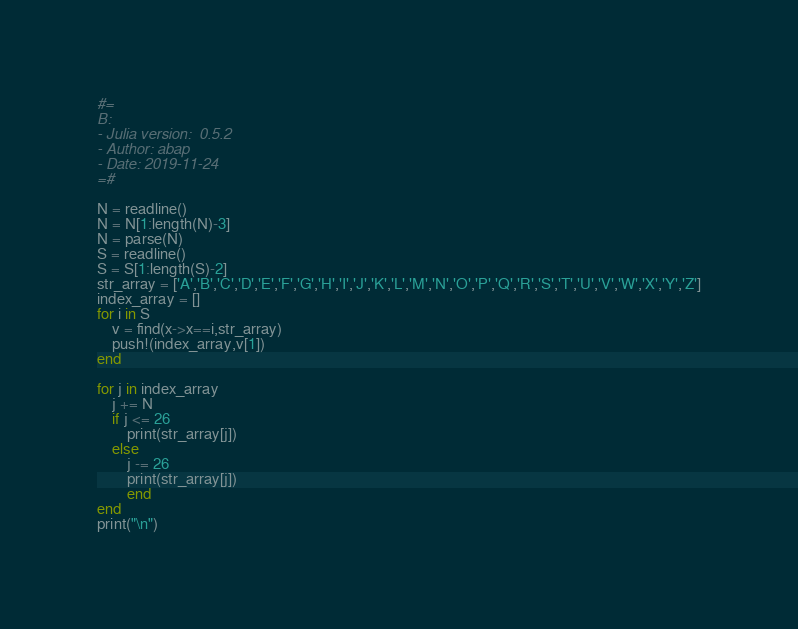<code> <loc_0><loc_0><loc_500><loc_500><_Julia_>#=
B:
- Julia version:  0.5.2
- Author: abap
- Date: 2019-11-24
=#

N = readline()
N = N[1:length(N)-3]
N = parse(N)
S = readline()
S = S[1:length(S)-2]
str_array = ['A','B','C','D','E','F','G','H','I','J','K','L','M','N','O','P','Q','R','S','T','U','V','W','X','Y','Z']
index_array = []
for i in S
    v = find(x->x==i,str_array)
    push!(index_array,v[1])
end

for j in index_array
    j += N
    if j <= 26
        print(str_array[j])
    else
        j -= 26
        print(str_array[j])
        end
end
print("\n")</code> 